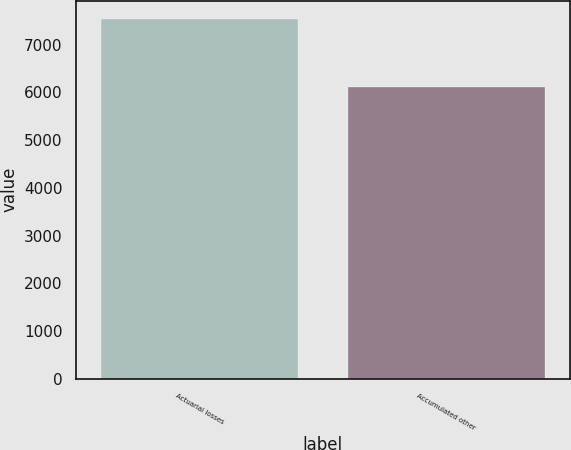Convert chart. <chart><loc_0><loc_0><loc_500><loc_500><bar_chart><fcel>Actuarial losses<fcel>Accumulated other<nl><fcel>7543<fcel>6104<nl></chart> 